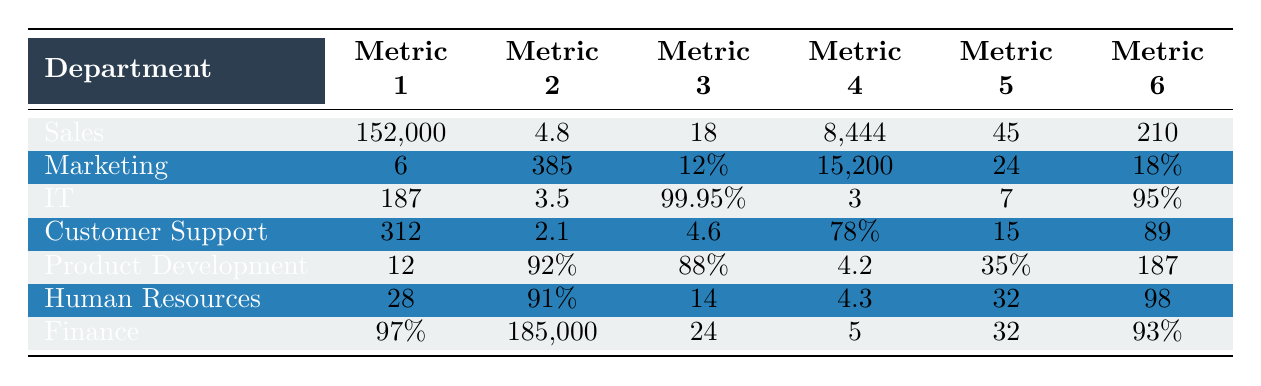What is the client satisfaction score for John Smith? From the table, we can find John Smith's entry under the Sales department. The corresponding client satisfaction score is listed as 4.8.
Answer: 4.8 How many deals did John Smith close? Looking under the Sales department for John Smith, the number of deals closed is recorded as 18.
Answer: 18 Which department has the highest average resolution time? The IT department, represented by Michael Chen, has an average resolution time of 3.5, which is higher than the other departments listed.
Answer: IT What is the combined total of tickets handled by Emily Rodriguez and Michael Chen? Emily Rodriguez handled 312 tickets, and Michael Chen resolved 187 tickets. Adding them together gives 312 + 187 = 499.
Answer: 499 Is the security incidents handled by Michael Chen greater than the deals closed by John Smith? Michael Chen handled 3 security incidents, which is less than John Smith's 18 deals closed. Thus, the answer is no.
Answer: No How many new hires did Lisa Patel onboard compared to the features shipped by David Kim? Lisa Patel onboarded 28 new hires, while David Kim shipped 12 features. The difference is 28 - 12 = 16.
Answer: 16 Which department has the highest customer satisfaction score? The Customer Support department (Emily Rodriguez) has the highest customer satisfaction score of 4.6. The Sales department's score of 4.8 is not a satisfaction score; it's different.
Answer: Customer Support What is the average employee satisfaction score across all departments? The average satisfaction scores are as follows: Sales (4.8), Customer Support (4.6), Product Development (4.2), and Human Resources (4.3). Summing these gives 4.8 + 4.6 + 4.2 + 4.3 = 18. Average is 18 / 4 = 4.5.
Answer: 4.5 Are there more positive feedback received by Emily Rodriguez than leads generated by Sarah Johnson? Emily Rodriguez received 89 positive feedback, while Sarah Johnson generated 385 leads. Since 89 is less than 385, the answer is no.
Answer: No Which employee has the best budget accuracy in Finance? Robert Thompson has a budget accuracy of 0.97, which is the only value provided for that metric in the Finance department.
Answer: Robert Thompson What is the total number of meetings scheduled and follow-up emails sent by John Smith? John Smith scheduled 45 meetings and sent 210 follow-up emails. Adding them gives 45 + 210 = 255.
Answer: 255 